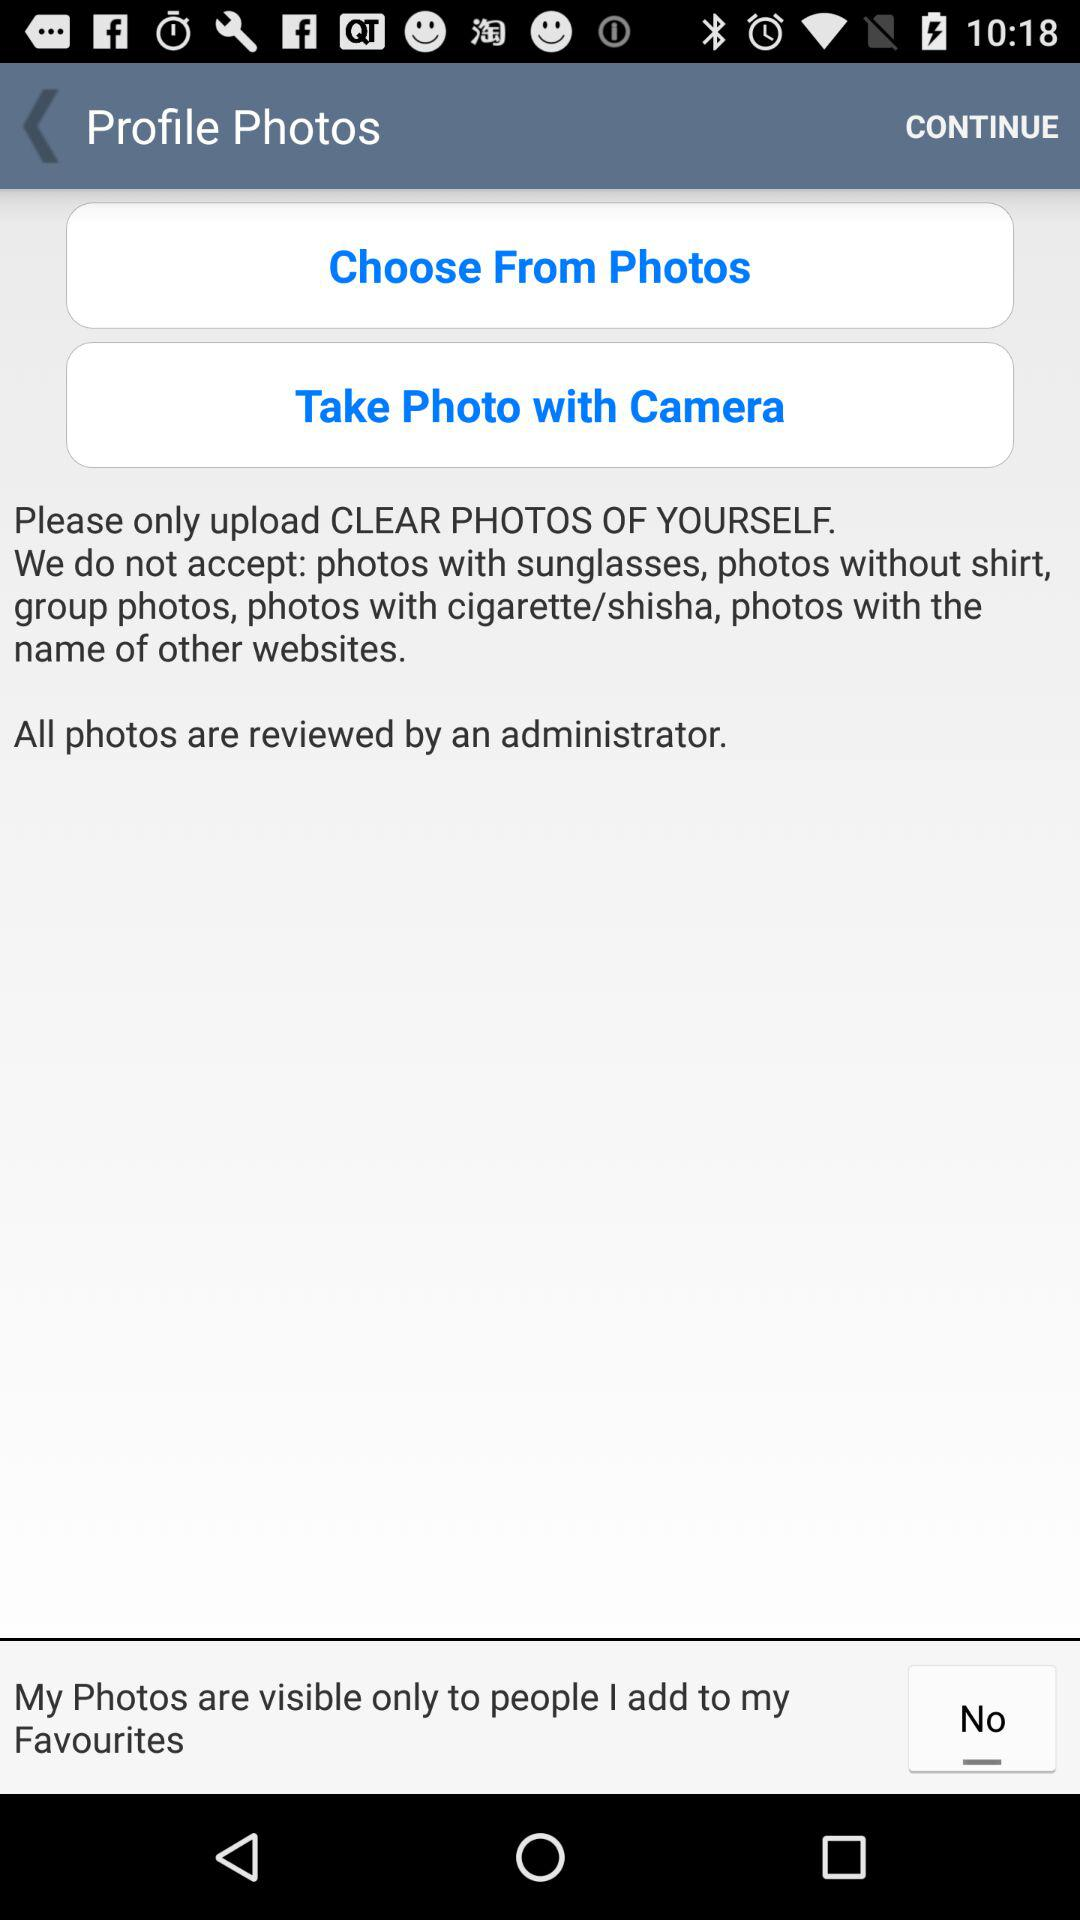Who will review all the photos? All photos will be reviewed by an administrator. 